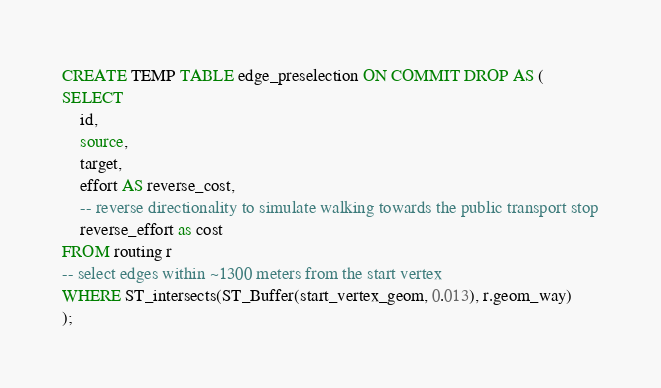<code> <loc_0><loc_0><loc_500><loc_500><_SQL_>CREATE TEMP TABLE edge_preselection ON COMMIT DROP AS (
SELECT
    id,
    source,
    target,
    effort AS reverse_cost, 
    -- reverse directionality to simulate walking towards the public transport stop
    reverse_effort as cost
FROM routing r
-- select edges within ~1300 meters from the start vertex
WHERE ST_intersects(ST_Buffer(start_vertex_geom, 0.013), r.geom_way)
);</code> 